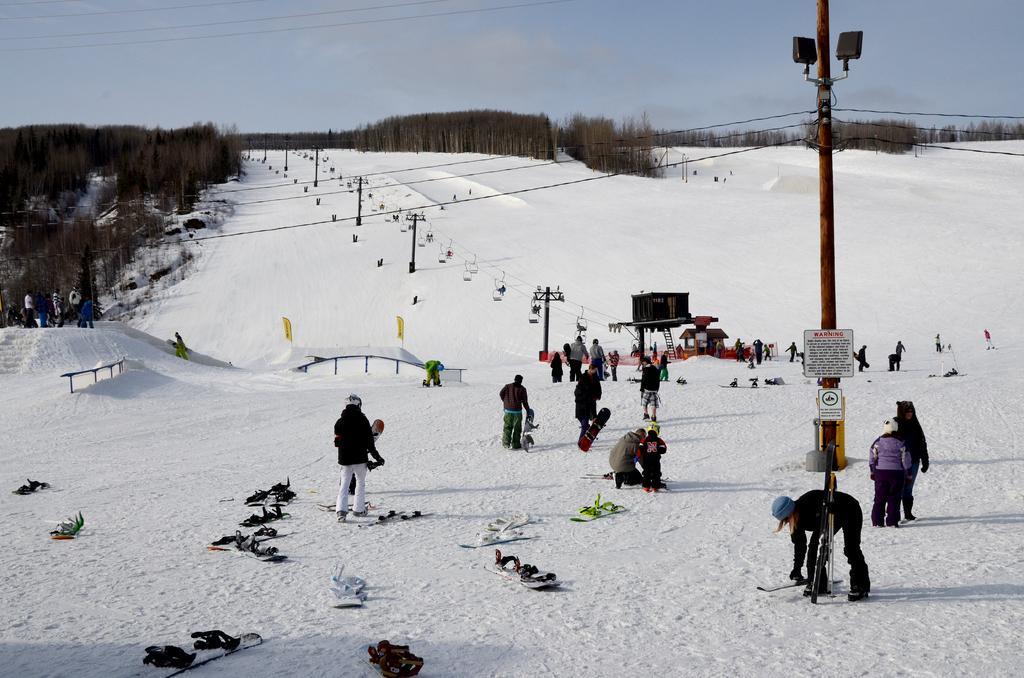Please provide a concise description of this image. In this picture we can see some people standing, at the bottom there is snow, we can see ski boards here, in the background there are some trees, we can see poles and lights here, there is a board here, we can see the sky at the top of the picture. 